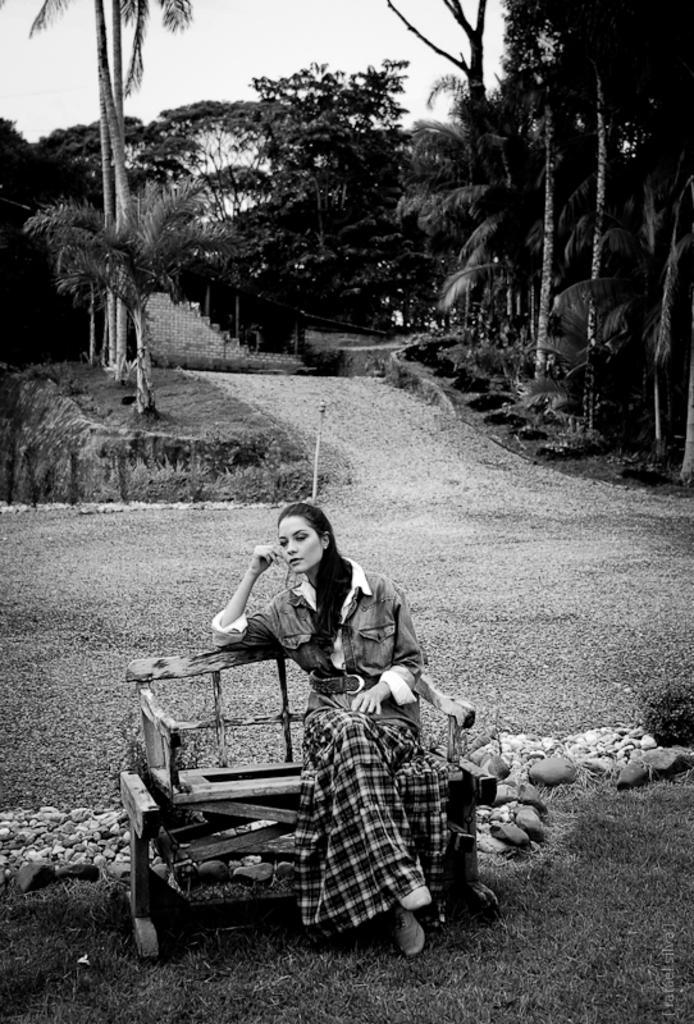Could you give a brief overview of what you see in this image? In this image we can see a black and white picture of a woman sitting on a chair and there are stones behind the chair and in the background there are few trees, a wall and the sky. 